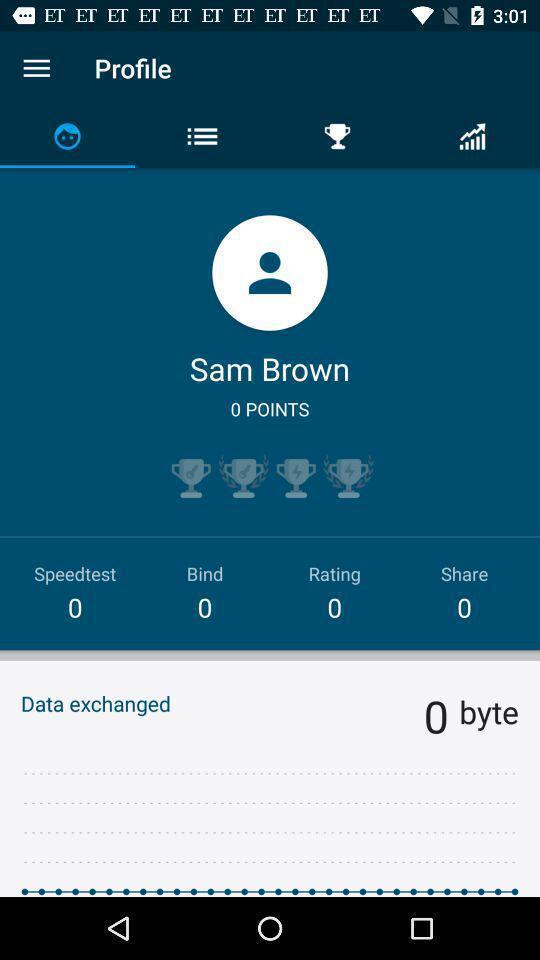Summarize the information in this screenshot. Screen shows profile details in communication application. 